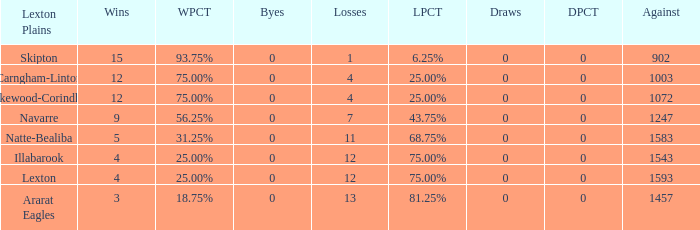What team has fewer than 9 wins and less than 1593 against? Natte-Bealiba, Illabarook, Ararat Eagles. 